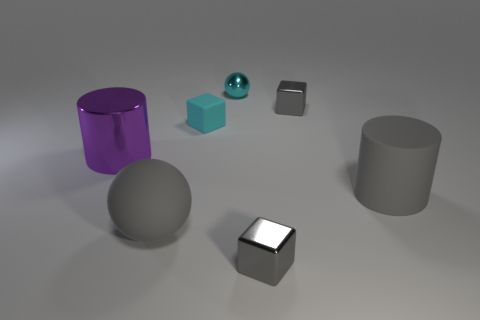Subtract all gray cubes. How many cubes are left? 1 Add 2 tiny cyan rubber cubes. How many objects exist? 9 Subtract all cyan blocks. How many blocks are left? 2 Subtract all spheres. How many objects are left? 5 Subtract 1 spheres. How many spheres are left? 1 Add 3 cyan spheres. How many cyan spheres are left? 4 Add 1 cyan metal things. How many cyan metal things exist? 2 Subtract 0 red blocks. How many objects are left? 7 Subtract all green cubes. Subtract all cyan cylinders. How many cubes are left? 3 Subtract all blue cubes. How many purple cylinders are left? 1 